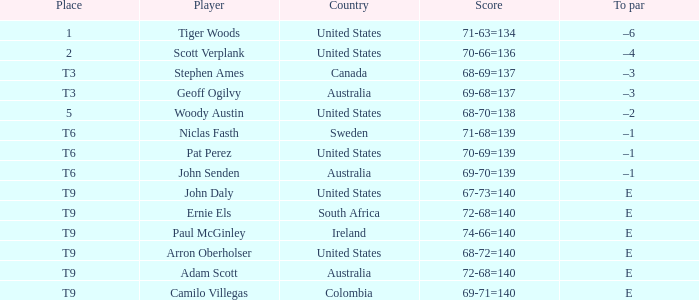In which nation does adam scott originate? Australia. 